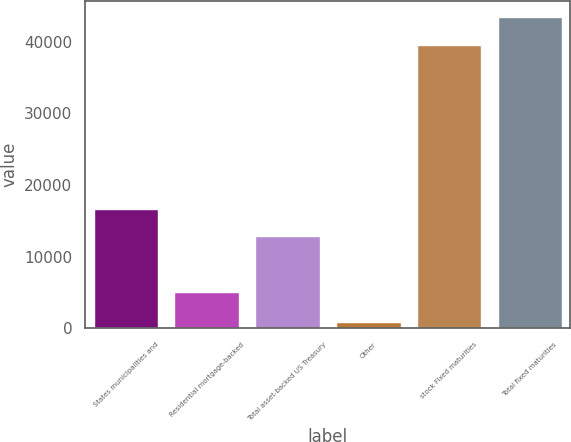Convert chart to OTSL. <chart><loc_0><loc_0><loc_500><loc_500><bar_chart><fcel>States municipalities and<fcel>Residential mortgage-backed<fcel>Total asset-backed US Treasury<fcel>Other<fcel>stock Fixed maturities<fcel>Total fixed maturities<nl><fcel>16706<fcel>5072<fcel>12828<fcel>921<fcel>39581<fcel>43459<nl></chart> 